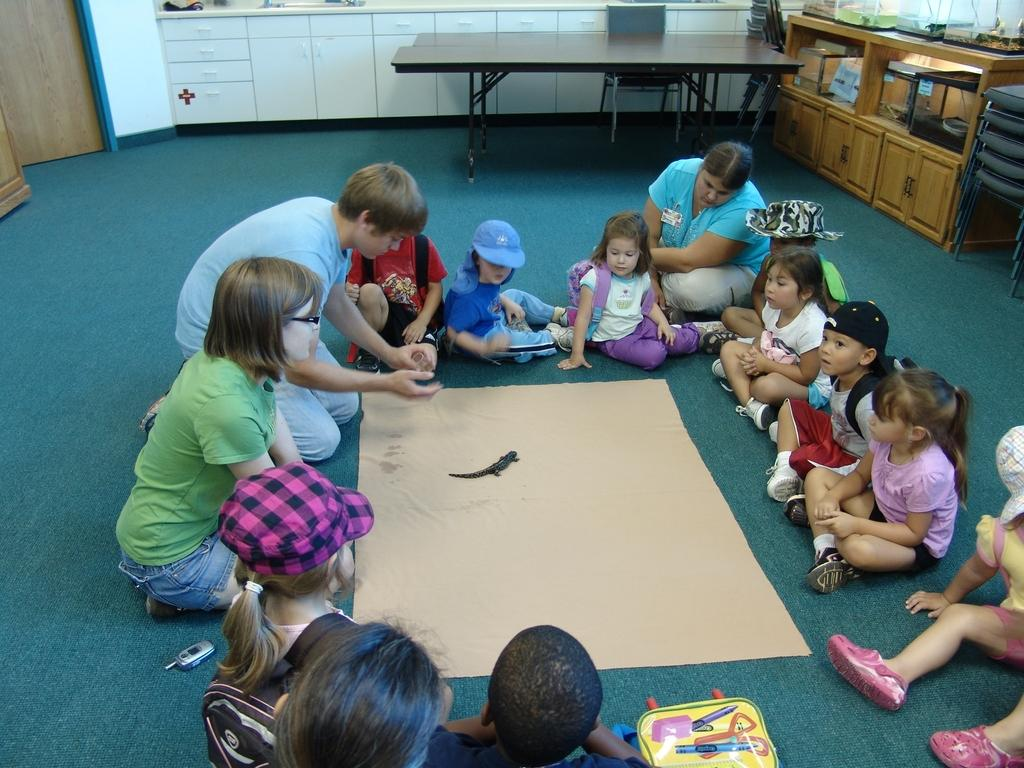What can be seen in the image involving a group of people? There is a group of children in the image. How are the children positioned in the image? The children are seated on the floor. What is on the floor near the children? There is a paper on the floor. Who else is present in the image besides the children? There is a woman in the image. Where is the woman located in relation to the children? The woman is among the children. What other object can be seen in the image? There is a table in the image. What type of doctor is attending to the children in the image? There is no doctor present in the image; it features a group of children seated on the floor with a woman among them and a table in the background. 